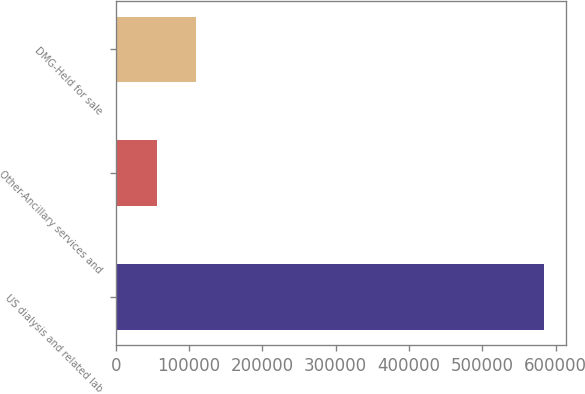Convert chart. <chart><loc_0><loc_0><loc_500><loc_500><bar_chart><fcel>US dialysis and related lab<fcel>Other-Ancillary services and<fcel>DMG-Held for sale<nl><fcel>584513<fcel>56685<fcel>109468<nl></chart> 